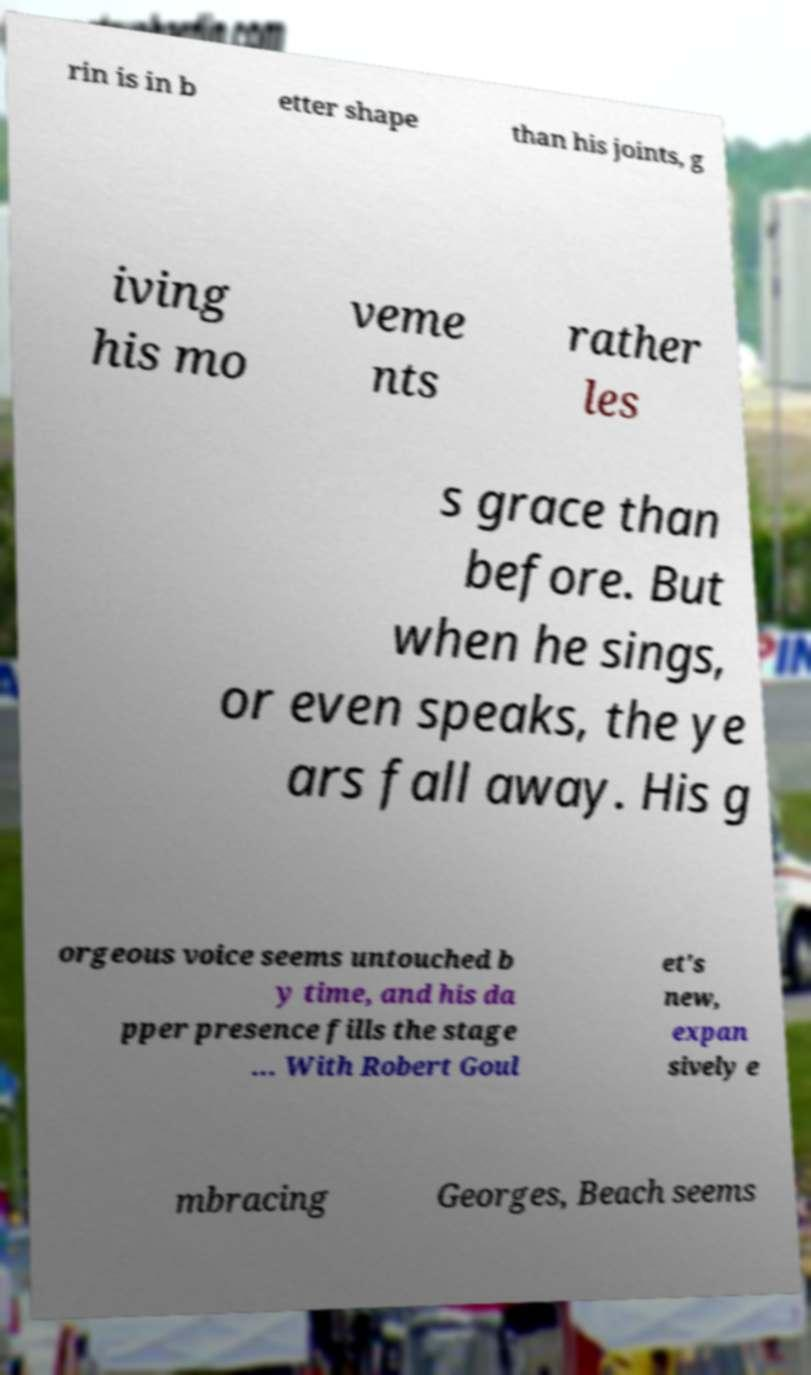Can you read and provide the text displayed in the image?This photo seems to have some interesting text. Can you extract and type it out for me? rin is in b etter shape than his joints, g iving his mo veme nts rather les s grace than before. But when he sings, or even speaks, the ye ars fall away. His g orgeous voice seems untouched b y time, and his da pper presence fills the stage ... With Robert Goul et's new, expan sively e mbracing Georges, Beach seems 